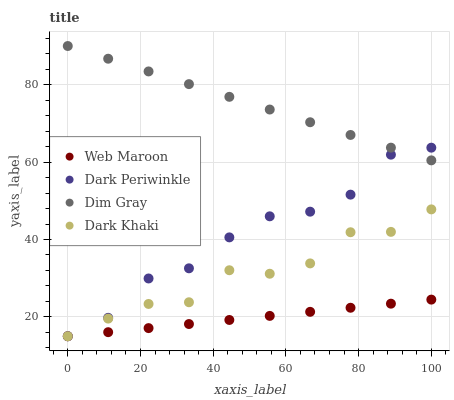Does Web Maroon have the minimum area under the curve?
Answer yes or no. Yes. Does Dim Gray have the maximum area under the curve?
Answer yes or no. Yes. Does Dim Gray have the minimum area under the curve?
Answer yes or no. No. Does Web Maroon have the maximum area under the curve?
Answer yes or no. No. Is Web Maroon the smoothest?
Answer yes or no. Yes. Is Dark Khaki the roughest?
Answer yes or no. Yes. Is Dim Gray the smoothest?
Answer yes or no. No. Is Dim Gray the roughest?
Answer yes or no. No. Does Dark Khaki have the lowest value?
Answer yes or no. Yes. Does Dim Gray have the lowest value?
Answer yes or no. No. Does Dim Gray have the highest value?
Answer yes or no. Yes. Does Web Maroon have the highest value?
Answer yes or no. No. Is Web Maroon less than Dim Gray?
Answer yes or no. Yes. Is Dim Gray greater than Web Maroon?
Answer yes or no. Yes. Does Dark Periwinkle intersect Dark Khaki?
Answer yes or no. Yes. Is Dark Periwinkle less than Dark Khaki?
Answer yes or no. No. Is Dark Periwinkle greater than Dark Khaki?
Answer yes or no. No. Does Web Maroon intersect Dim Gray?
Answer yes or no. No. 